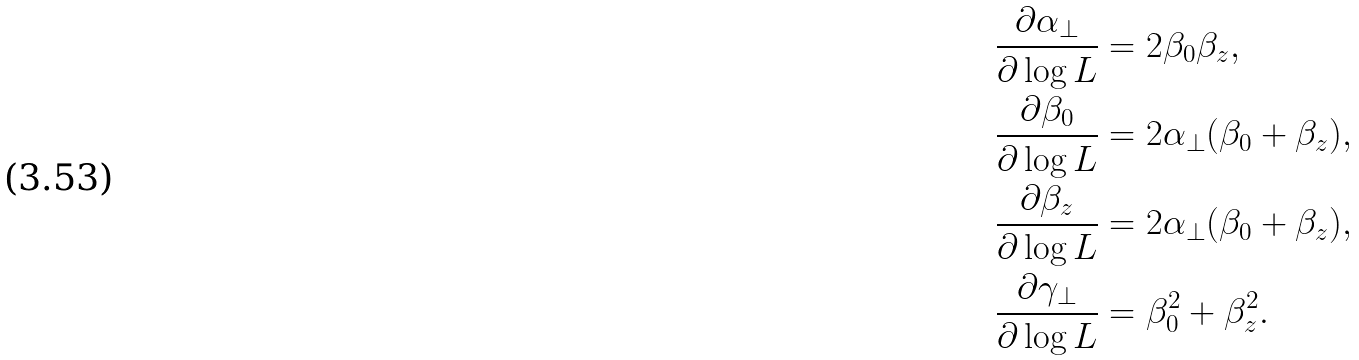Convert formula to latex. <formula><loc_0><loc_0><loc_500><loc_500>\frac { \partial { \alpha _ { \perp } } } { \partial \log L } & = 2 \beta _ { 0 } \beta _ { z } , \\ \frac { \partial { \beta _ { 0 } } } { \partial \log L } & = 2 \alpha _ { \perp } ( \beta _ { 0 } + \beta _ { z } ) , \\ \frac { \partial { \beta _ { z } } } { \partial \log L } & = 2 \alpha _ { \perp } ( \beta _ { 0 } + \beta _ { z } ) , \\ \frac { \partial { \gamma _ { \perp } } } { \partial \log L } & = \beta _ { 0 } ^ { 2 } + \beta _ { z } ^ { 2 } .</formula> 